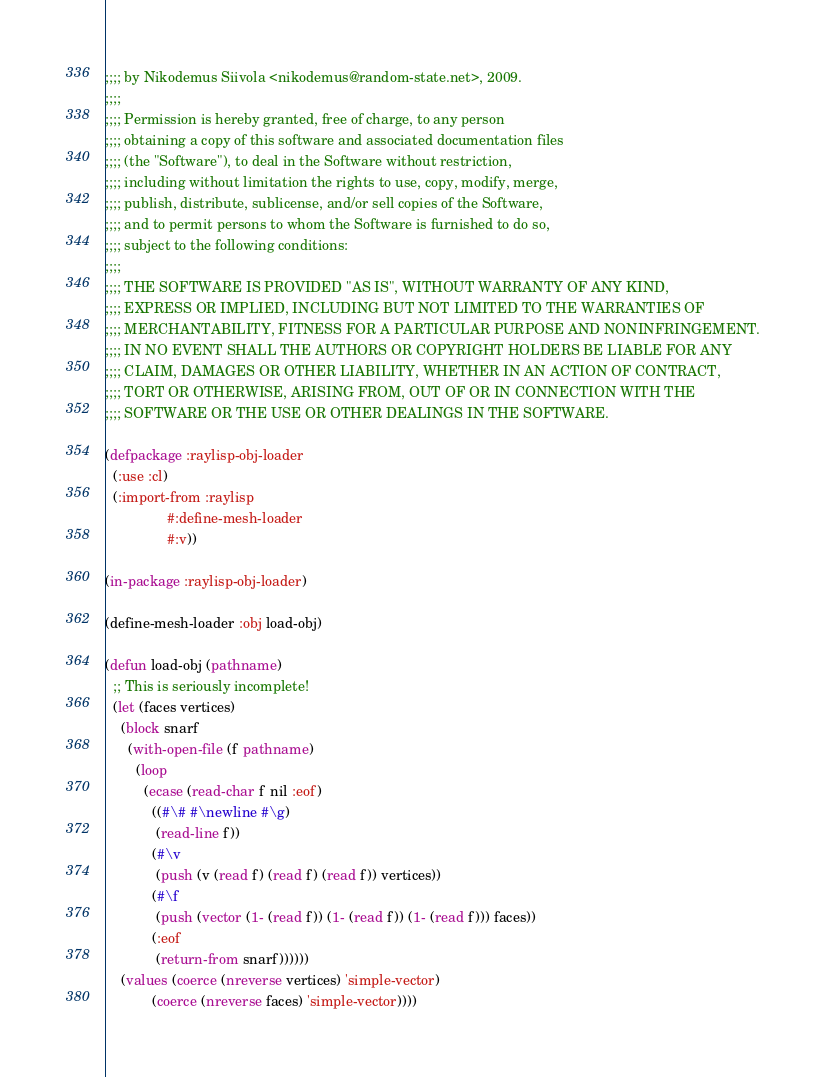<code> <loc_0><loc_0><loc_500><loc_500><_Lisp_>;;;; by Nikodemus Siivola <nikodemus@random-state.net>, 2009.
;;;;
;;;; Permission is hereby granted, free of charge, to any person
;;;; obtaining a copy of this software and associated documentation files
;;;; (the "Software"), to deal in the Software without restriction,
;;;; including without limitation the rights to use, copy, modify, merge,
;;;; publish, distribute, sublicense, and/or sell copies of the Software,
;;;; and to permit persons to whom the Software is furnished to do so,
;;;; subject to the following conditions:
;;;;
;;;; THE SOFTWARE IS PROVIDED "AS IS", WITHOUT WARRANTY OF ANY KIND,
;;;; EXPRESS OR IMPLIED, INCLUDING BUT NOT LIMITED TO THE WARRANTIES OF
;;;; MERCHANTABILITY, FITNESS FOR A PARTICULAR PURPOSE AND NONINFRINGEMENT.
;;;; IN NO EVENT SHALL THE AUTHORS OR COPYRIGHT HOLDERS BE LIABLE FOR ANY
;;;; CLAIM, DAMAGES OR OTHER LIABILITY, WHETHER IN AN ACTION OF CONTRACT,
;;;; TORT OR OTHERWISE, ARISING FROM, OUT OF OR IN CONNECTION WITH THE
;;;; SOFTWARE OR THE USE OR OTHER DEALINGS IN THE SOFTWARE.

(defpackage :raylisp-obj-loader
  (:use :cl)
  (:import-from :raylisp
                #:define-mesh-loader
                #:v))

(in-package :raylisp-obj-loader)

(define-mesh-loader :obj load-obj)

(defun load-obj (pathname)
  ;; This is seriously incomplete!
  (let (faces vertices)
    (block snarf
      (with-open-file (f pathname)
        (loop
          (ecase (read-char f nil :eof)
            ((#\# #\newline #\g)
             (read-line f))
            (#\v
             (push (v (read f) (read f) (read f)) vertices))
            (#\f
             (push (vector (1- (read f)) (1- (read f)) (1- (read f))) faces))
            (:eof
             (return-from snarf))))))
    (values (coerce (nreverse vertices) 'simple-vector)
            (coerce (nreverse faces) 'simple-vector))))
</code> 